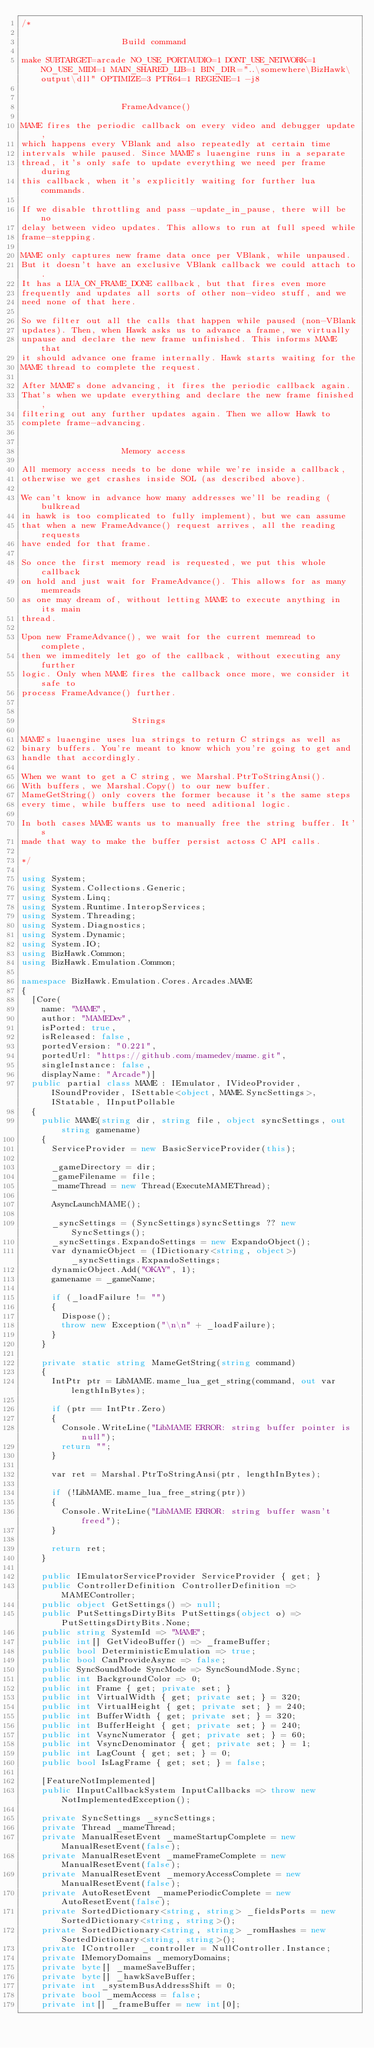Convert code to text. <code><loc_0><loc_0><loc_500><loc_500><_C#_>/*

                    Build command

make SUBTARGET=arcade NO_USE_PORTAUDIO=1 DONT_USE_NETWORK=1 NO_USE_MIDI=1 MAIN_SHARED_LIB=1 BIN_DIR="..\somewhere\BizHawk\output\dll" OPTIMIZE=3 PTR64=1 REGENIE=1 -j8


                    FrameAdvance()

MAME fires the periodic callback on every video and debugger update,
which happens every VBlank and also repeatedly at certain time
intervals while paused. Since MAME's luaengine runs in a separate
thread, it's only safe to update everything we need per frame during
this callback, when it's explicitly waiting for further lua commands.

If we disable throttling and pass -update_in_pause, there will be no
delay between video updates. This allows to run at full speed while
frame-stepping.

MAME only captures new frame data once per VBlank, while unpaused.
But it doesn't have an exclusive VBlank callback we could attach to.
It has a LUA_ON_FRAME_DONE callback, but that fires even more
frequently and updates all sorts of other non-video stuff, and we
need none of that here.

So we filter out all the calls that happen while paused (non-VBlank
updates). Then, when Hawk asks us to advance a frame, we virtually
unpause and declare the new frame unfinished. This informs MAME that
it should advance one frame internally. Hawk starts waiting for the
MAME thread to complete the request.

After MAME's done advancing, it fires the periodic callback again.
That's when we update everything and declare the new frame finished,
filtering out any further updates again. Then we allow Hawk to
complete frame-advancing.


                    Memory access

All memory access needs to be done while we're inside a callback,
otherwise we get crashes inside SOL (as described above).

We can't know in advance how many addresses we'll be reading (bulkread
in hawk is too complicated to fully implement), but we can assume
that when a new FrameAdvance() request arrives, all the reading requests
have ended for that frame.

So once the first memory read is requested, we put this whole callback
on hold and just wait for FrameAdvance(). This allows for as many memreads
as one may dream of, without letting MAME to execute anything in its main
thread.

Upon new FrameAdvance(), we wait for the current memread to complete,
then we immeditely let go of the callback, without executing any further
logic. Only when MAME fires the callback once more, we consider it safe to
process FrameAdvance() further.


                      Strings

MAME's luaengine uses lua strings to return C strings as well as
binary buffers. You're meant to know which you're going to get and
handle that accordingly.

When we want to get a C string, we Marshal.PtrToStringAnsi().
With buffers, we Marshal.Copy() to our new buffer.
MameGetString() only covers the former because it's the same steps
every time, while buffers use to need aditional logic.

In both cases MAME wants us to manually free the string buffer. It's
made that way to make the buffer persist actoss C API calls.

*/

using System;
using System.Collections.Generic;
using System.Linq;
using System.Runtime.InteropServices;
using System.Threading;
using System.Diagnostics;
using System.Dynamic;
using System.IO;
using BizHawk.Common;
using BizHawk.Emulation.Common;

namespace BizHawk.Emulation.Cores.Arcades.MAME
{
	[Core(
		name: "MAME",
		author: "MAMEDev",
		isPorted: true,
		isReleased: false,
		portedVersion: "0.221",
		portedUrl: "https://github.com/mamedev/mame.git",
		singleInstance: false,
		displayName: "Arcade")]
	public partial class MAME : IEmulator, IVideoProvider, ISoundProvider, ISettable<object, MAME.SyncSettings>, IStatable, IInputPollable
	{
		public MAME(string dir, string file, object syncSettings, out string gamename)
		{
			ServiceProvider = new BasicServiceProvider(this);

			_gameDirectory = dir;
			_gameFilename = file;
			_mameThread = new Thread(ExecuteMAMEThread);

			AsyncLaunchMAME();

			_syncSettings = (SyncSettings)syncSettings ?? new SyncSettings();
			_syncSettings.ExpandoSettings = new ExpandoObject();
			var dynamicObject = (IDictionary<string, object>)_syncSettings.ExpandoSettings;
			dynamicObject.Add("OKAY", 1);
			gamename = _gameName;

			if (_loadFailure != "")
			{
				Dispose();
				throw new Exception("\n\n" + _loadFailure);
			}
		}

		private static string MameGetString(string command)
		{
			IntPtr ptr = LibMAME.mame_lua_get_string(command, out var lengthInBytes);

			if (ptr == IntPtr.Zero)
			{
				Console.WriteLine("LibMAME ERROR: string buffer pointer is null");
				return "";
			}

			var ret = Marshal.PtrToStringAnsi(ptr, lengthInBytes);

			if (!LibMAME.mame_lua_free_string(ptr))
			{
				Console.WriteLine("LibMAME ERROR: string buffer wasn't freed");
			}

			return ret;
		}

		public IEmulatorServiceProvider ServiceProvider { get; }
		public ControllerDefinition ControllerDefinition => MAMEController;
		public object GetSettings() => null;
		public PutSettingsDirtyBits PutSettings(object o) => PutSettingsDirtyBits.None;
		public string SystemId => "MAME";
		public int[] GetVideoBuffer() => _frameBuffer;
		public bool DeterministicEmulation => true;
		public bool CanProvideAsync => false;
		public SyncSoundMode SyncMode => SyncSoundMode.Sync;
		public int BackgroundColor => 0;
		public int Frame { get; private set; }
		public int VirtualWidth { get; private set; } = 320;
		public int VirtualHeight { get; private set; } = 240;
		public int BufferWidth { get; private set; } = 320;
		public int BufferHeight { get; private set; } = 240;
		public int VsyncNumerator { get; private set; } = 60;
		public int VsyncDenominator { get; private set; } = 1;
		public int LagCount { get; set; } = 0;
		public bool IsLagFrame { get; set; } = false;

		[FeatureNotImplemented]
		public IInputCallbackSystem InputCallbacks => throw new NotImplementedException();

		private SyncSettings _syncSettings;
		private Thread _mameThread;
		private ManualResetEvent _mameStartupComplete = new ManualResetEvent(false);
		private ManualResetEvent _mameFrameComplete = new ManualResetEvent(false);
		private ManualResetEvent _memoryAccessComplete = new ManualResetEvent(false);
		private AutoResetEvent _mamePeriodicComplete = new AutoResetEvent(false);
		private SortedDictionary<string, string> _fieldsPorts = new SortedDictionary<string, string>();
		private SortedDictionary<string, string> _romHashes = new SortedDictionary<string, string>();
		private IController _controller = NullController.Instance;
		private IMemoryDomains _memoryDomains;
		private byte[] _mameSaveBuffer;
		private byte[] _hawkSaveBuffer;
		private int _systemBusAddressShift = 0;
		private bool _memAccess = false;
		private int[] _frameBuffer = new int[0];</code> 